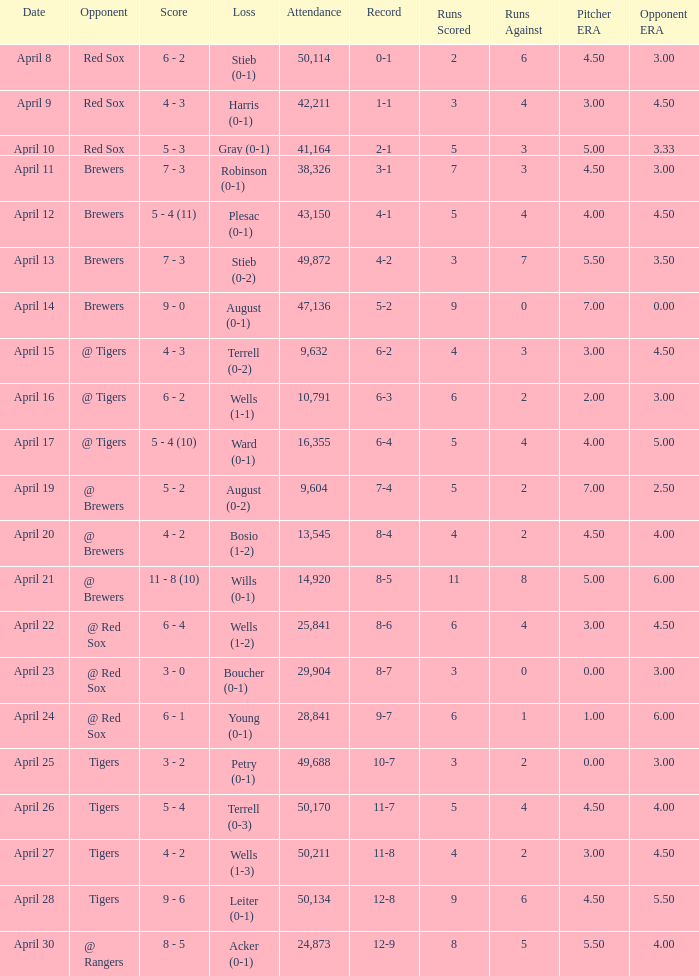What is the largest attendance that has tigers as the opponent and a loss of leiter (0-1)? 50134.0. 